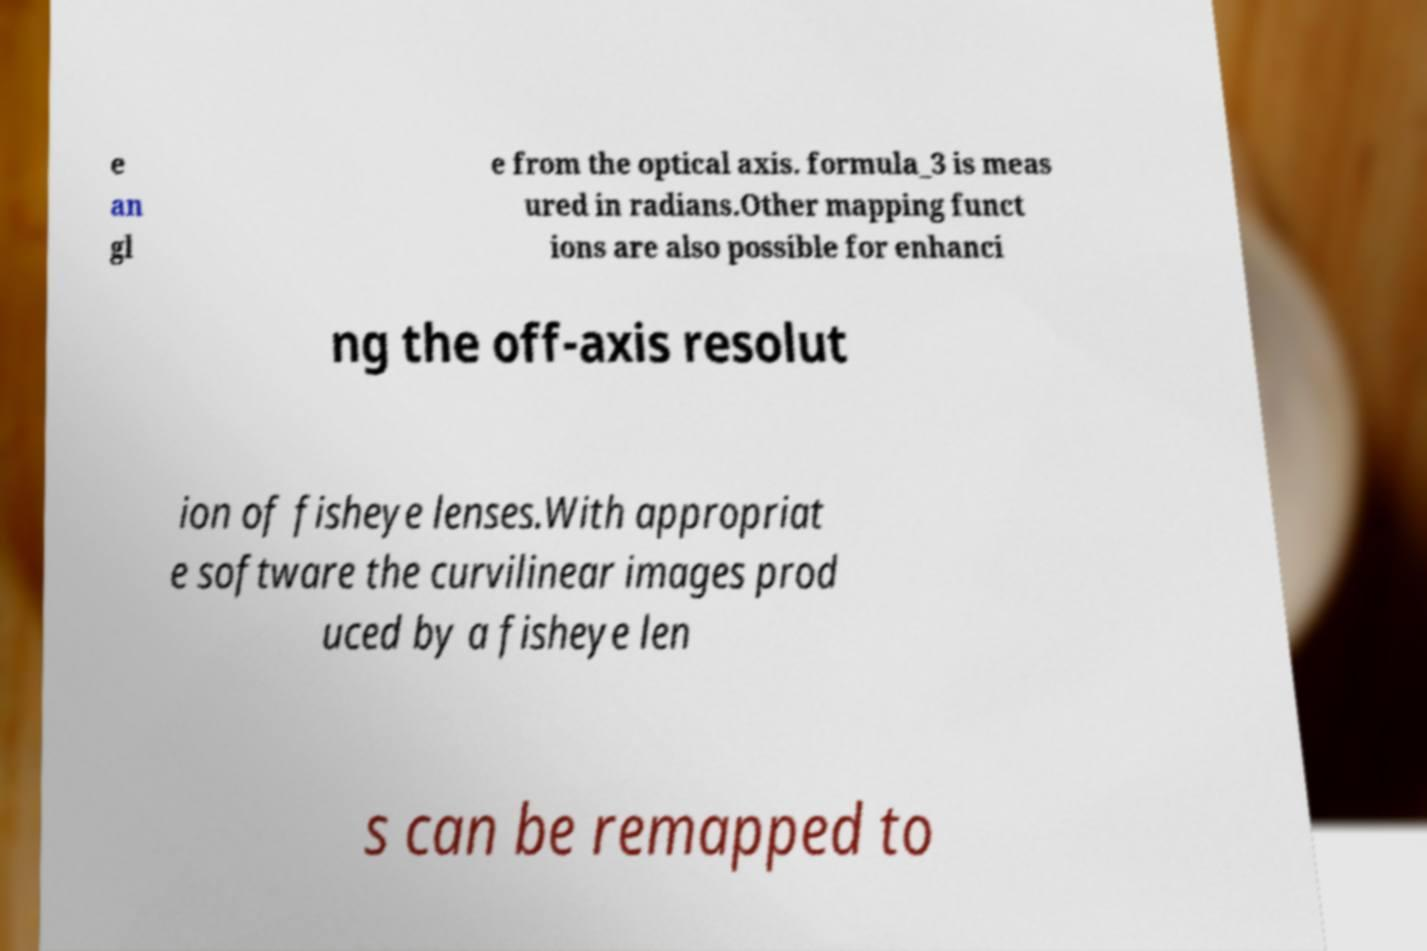Please read and relay the text visible in this image. What does it say? e an gl e from the optical axis. formula_3 is meas ured in radians.Other mapping funct ions are also possible for enhanci ng the off-axis resolut ion of fisheye lenses.With appropriat e software the curvilinear images prod uced by a fisheye len s can be remapped to 